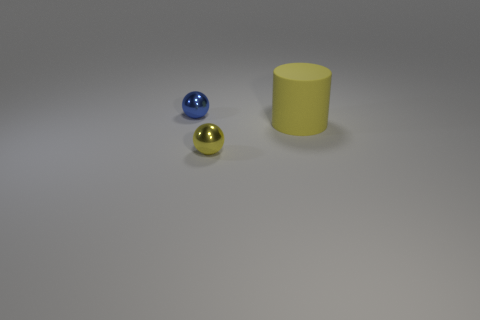Add 3 big matte cylinders. How many objects exist? 6 Subtract all balls. How many objects are left? 1 Add 3 small balls. How many small balls are left? 5 Add 2 big red metal blocks. How many big red metal blocks exist? 2 Subtract 0 red blocks. How many objects are left? 3 Subtract all brown balls. Subtract all purple cylinders. How many balls are left? 2 Subtract all cyan cubes. How many yellow balls are left? 1 Subtract all red cubes. Subtract all tiny yellow objects. How many objects are left? 2 